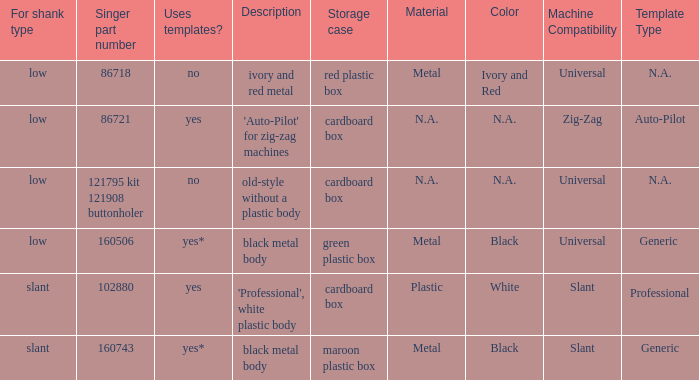What's the singer part number of the buttonholer whose storage case is a green plastic box? 160506.0. 